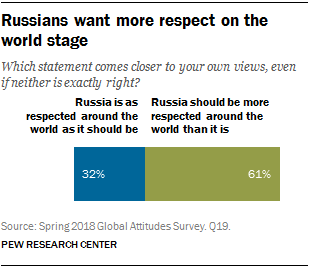Point out several critical features in this image. The larger bar has a value of 61. The ratio between two opinions is 0.043055556 followed by an infinite number of decimal places. 